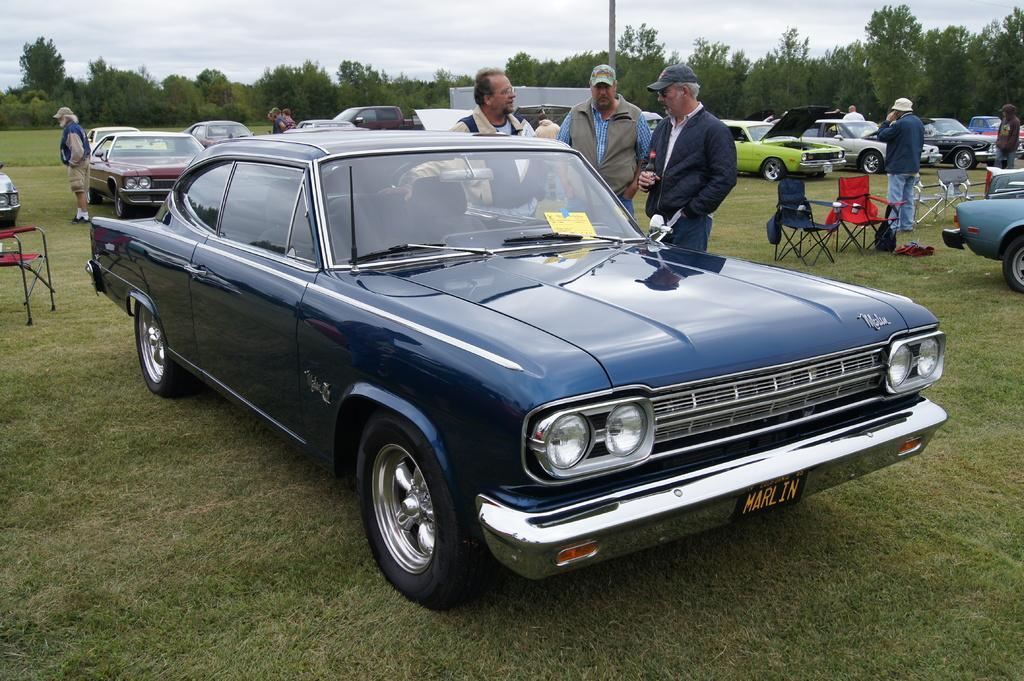Provide a one-sentence caption for the provided image. The blue car in the picture is from the California. 